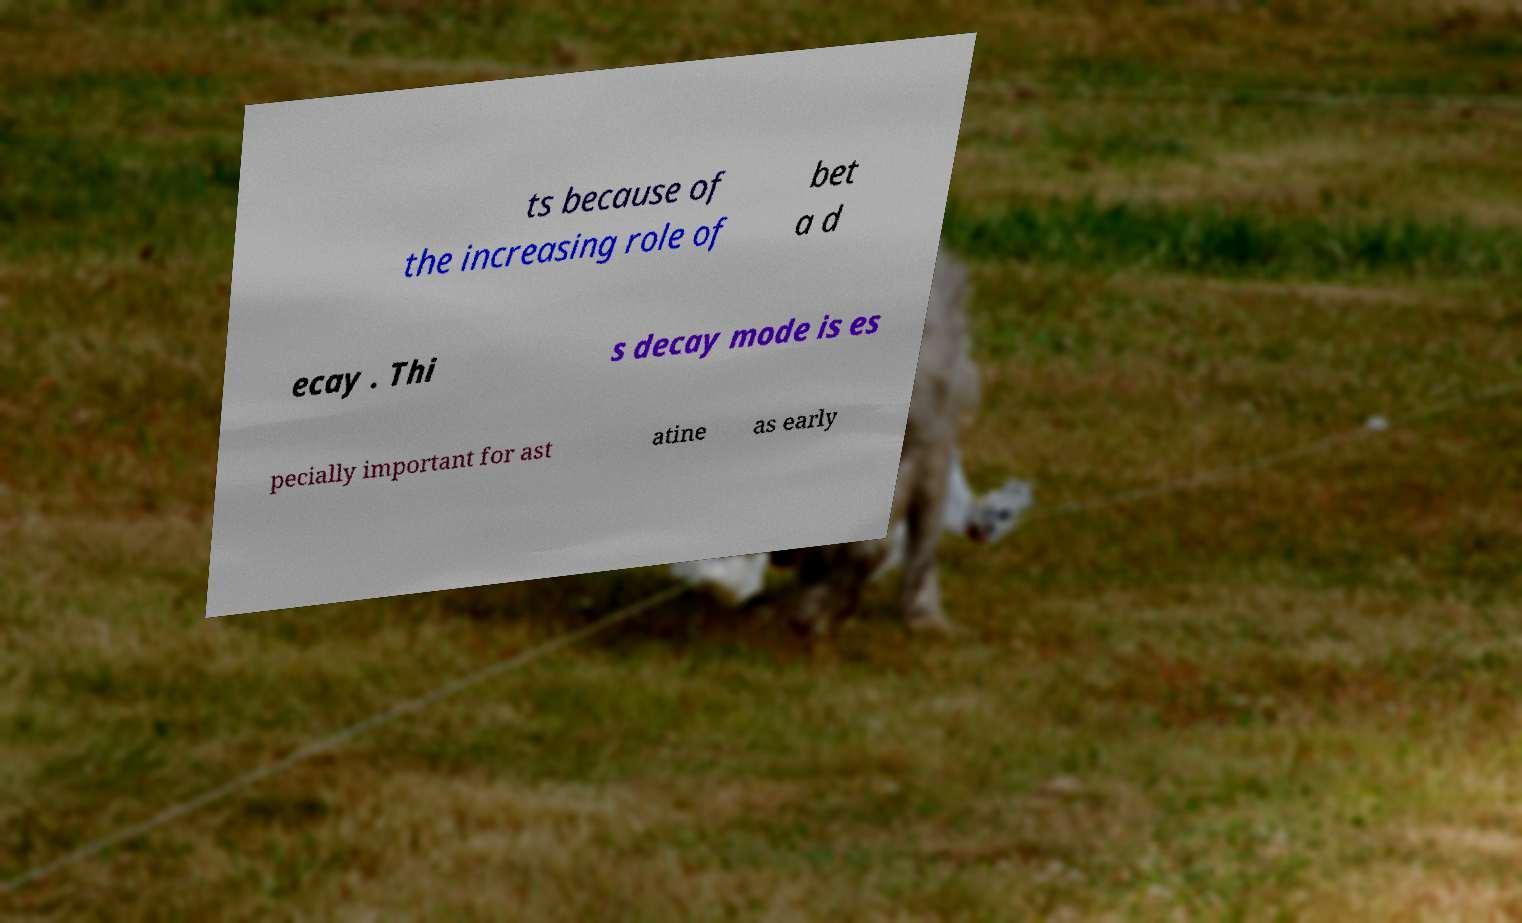Could you assist in decoding the text presented in this image and type it out clearly? ts because of the increasing role of bet a d ecay . Thi s decay mode is es pecially important for ast atine as early 